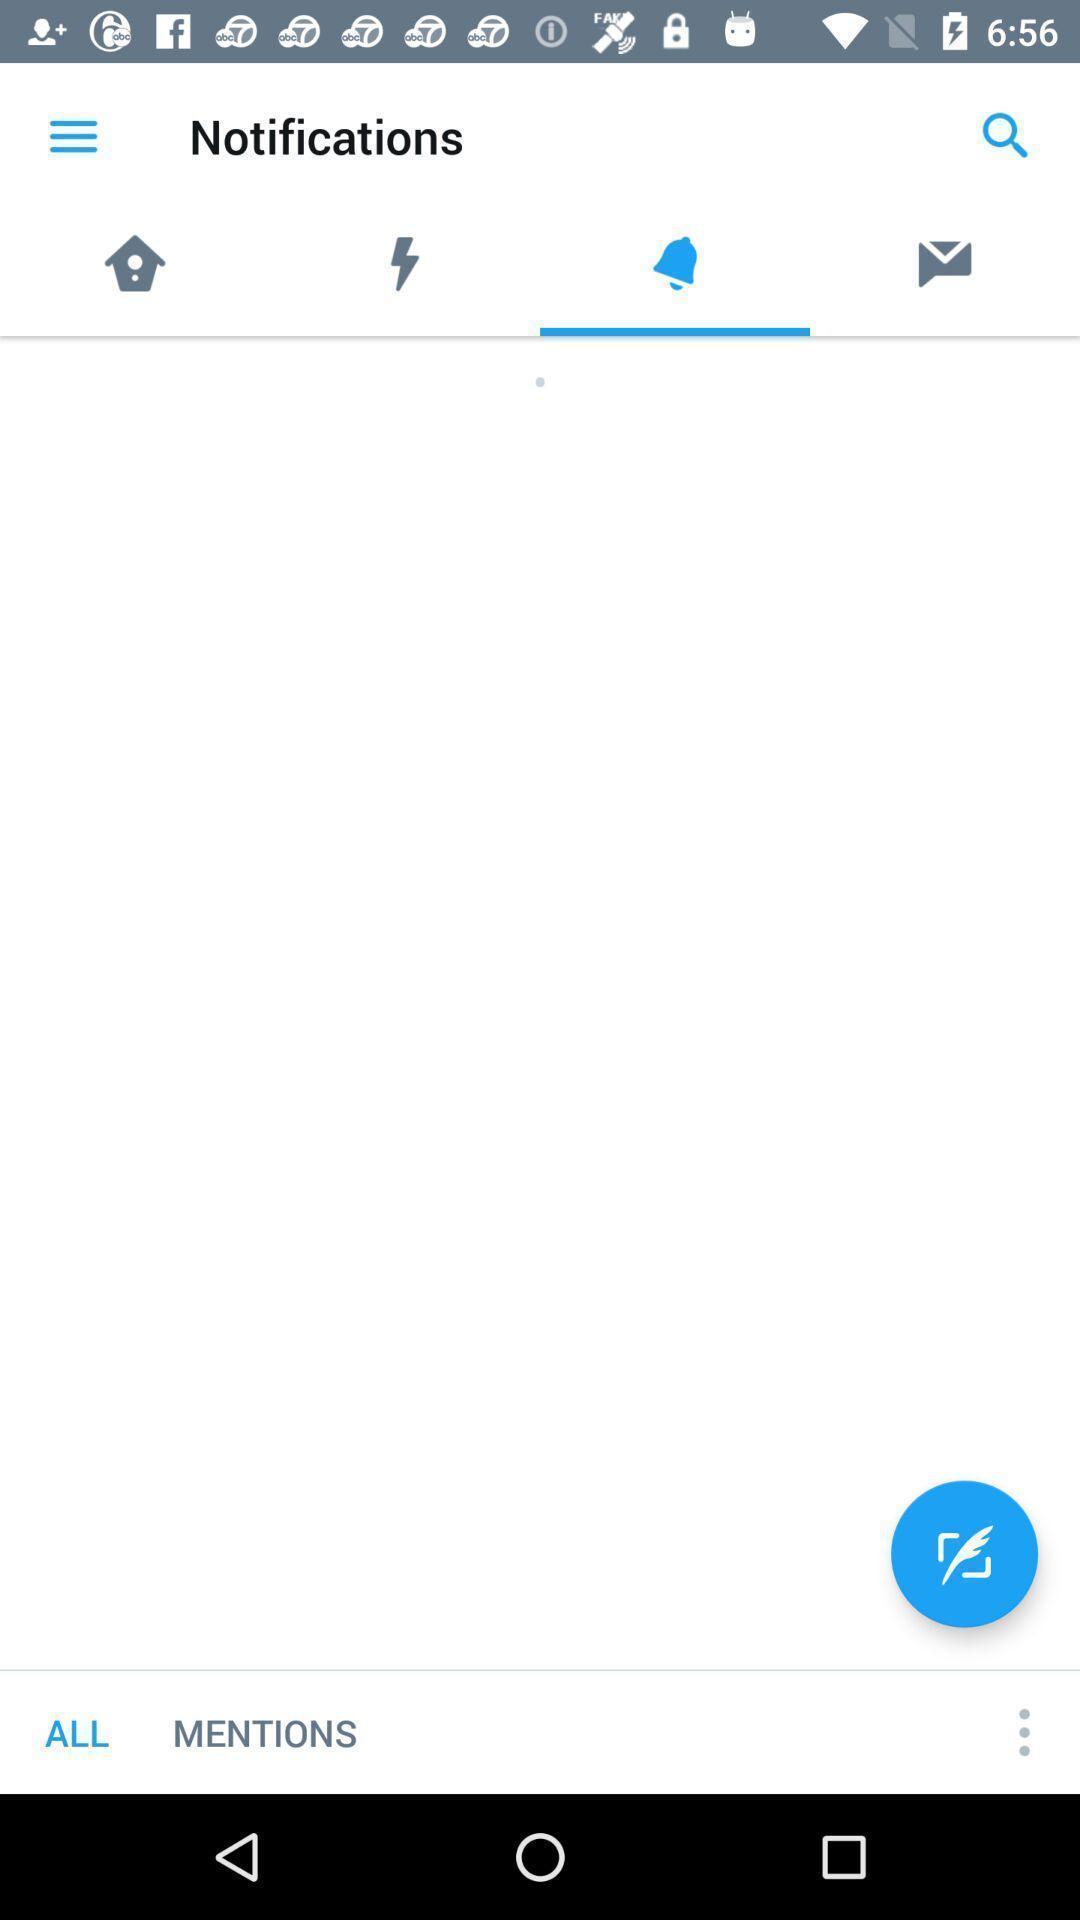Provide a textual representation of this image. Screen page of a notifications in a social app. 